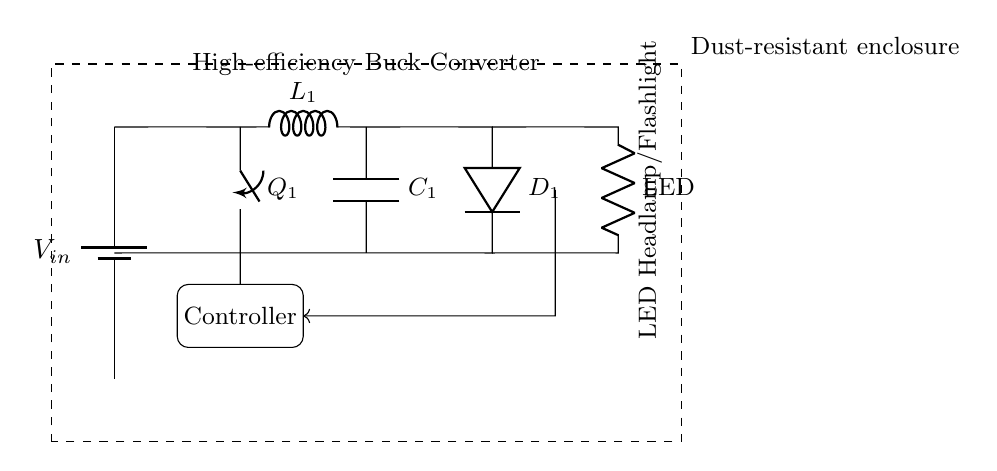What is the input voltage of this circuit? The circuit shows a battery labeled V_in as the power source, which indicates that this is the input voltage for the circuit.
Answer: V_in What type of converter is used in this circuit? The diagram labels a component as a "High-efficiency Buck Converter," indicating the type of converter utilized, which steps down the voltage efficiently.
Answer: Buck Converter What is the function of the inductor in this circuit? The inductor, labeled L_1, is part of the buck converter and helps to store energy, smoothing out the current flow to improve efficiency during the voltage conversion.
Answer: Energy storage What are the main components of the dust-resistant enclosure? The dust-resistant enclosure is represented as a dashed rectangle surrounding the circuit, implying that all components within the rectangle are protected from dust.
Answer: All components What does the feedback arrow indicate in this circuit? The feedback arrow points from the LED back towards the controller, indicating that the LED's performance may influence or regulate the functioning of the converter through the controller.
Answer: Regulation How does the controller interact with the circuit? The controller, shown as a rectangular block, receives input from component Q1 and controls the operation of the circuit based on the feedback received from the LED to optimize performance.
Answer: Regulation What component detects the current in this circuit? The current sensing occurs at component Q1, which is a switch that can determine the current levels and help in controlling the power output accordingly.
Answer: Q1 